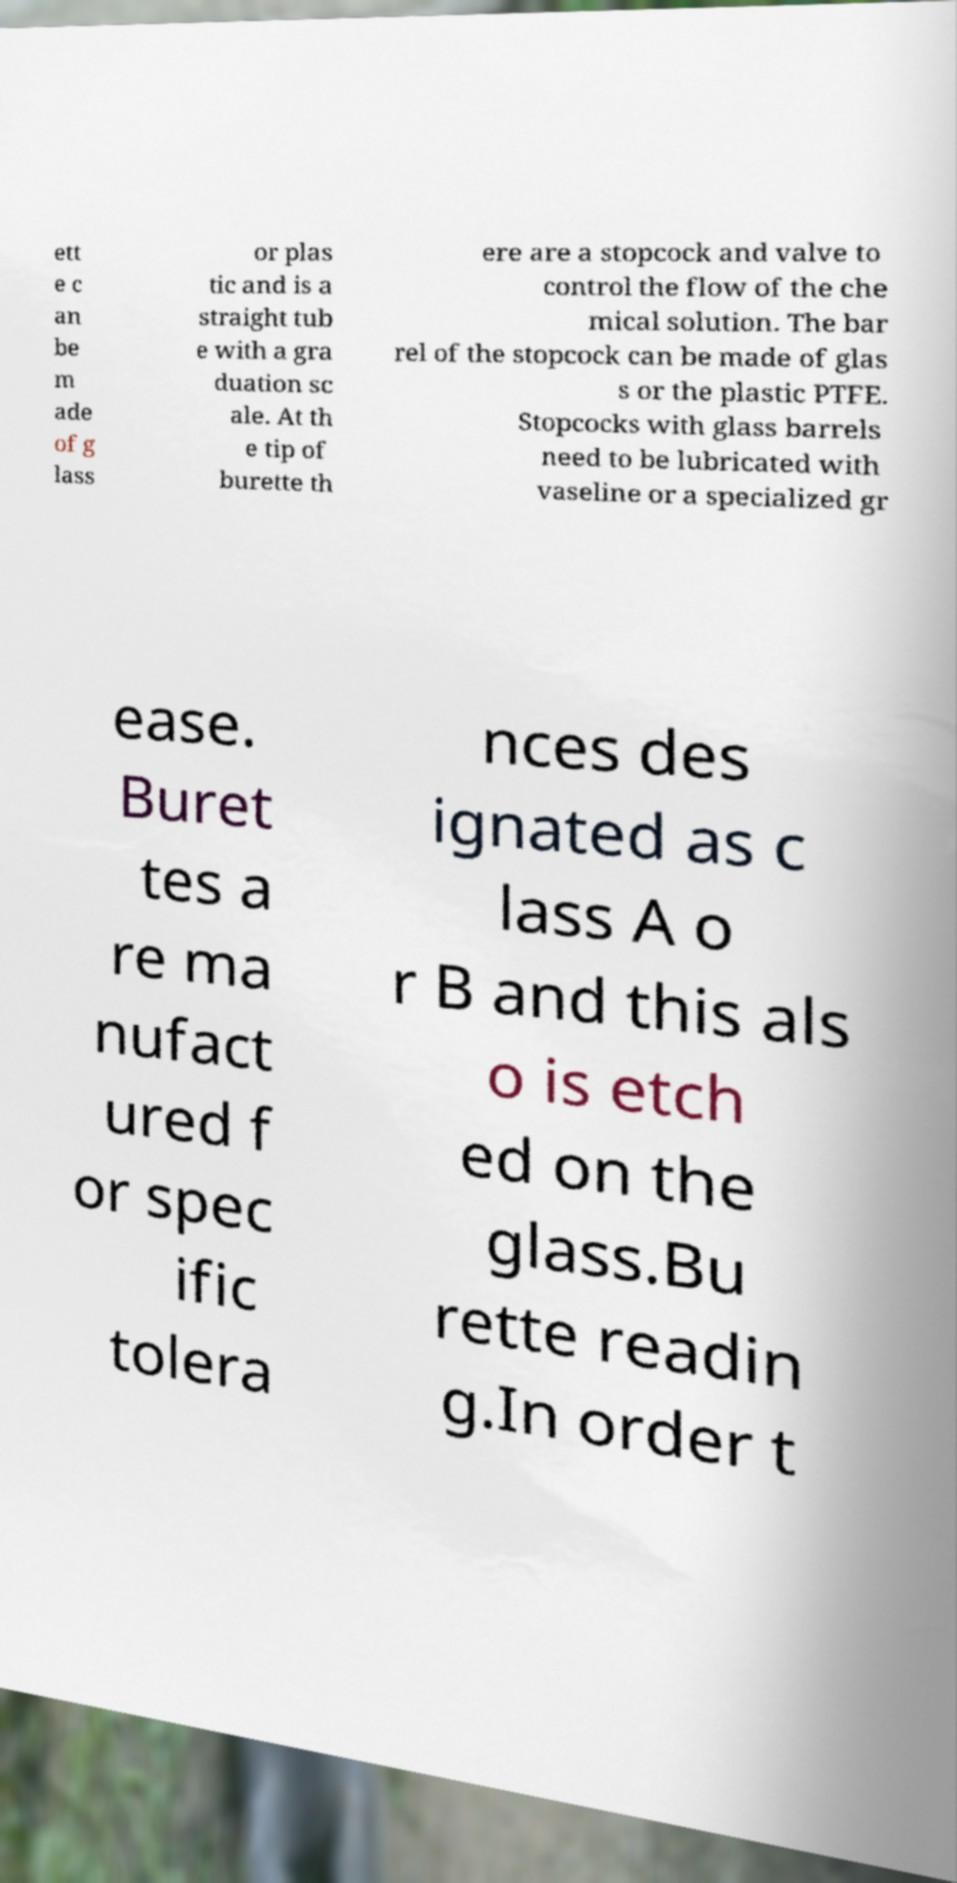I need the written content from this picture converted into text. Can you do that? ett e c an be m ade of g lass or plas tic and is a straight tub e with a gra duation sc ale. At th e tip of burette th ere are a stopcock and valve to control the flow of the che mical solution. The bar rel of the stopcock can be made of glas s or the plastic PTFE. Stopcocks with glass barrels need to be lubricated with vaseline or a specialized gr ease. Buret tes a re ma nufact ured f or spec ific tolera nces des ignated as c lass A o r B and this als o is etch ed on the glass.Bu rette readin g.In order t 